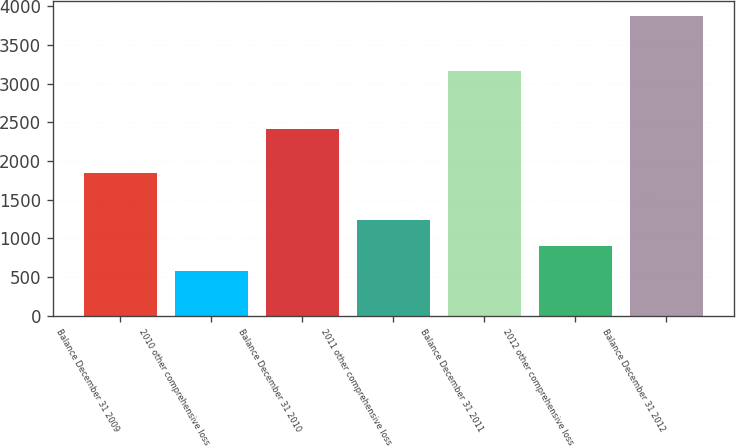Convert chart. <chart><loc_0><loc_0><loc_500><loc_500><bar_chart><fcel>Balance December 31 2009<fcel>2010 other comprehensive loss<fcel>Balance December 31 2010<fcel>2011 other comprehensive loss<fcel>Balance December 31 2011<fcel>2012 other comprehensive loss<fcel>Balance December 31 2012<nl><fcel>1842<fcel>575<fcel>2417<fcel>1236<fcel>3162<fcel>905.5<fcel>3880<nl></chart> 